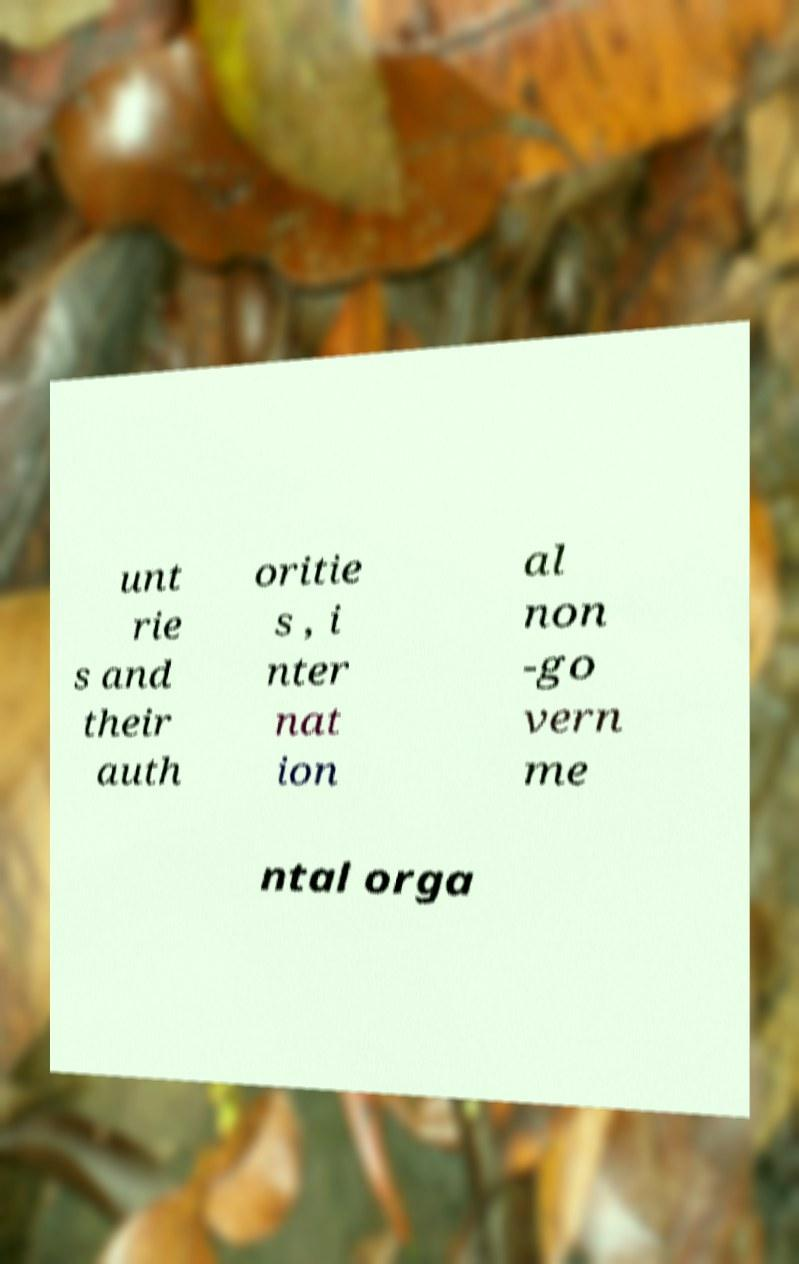Could you assist in decoding the text presented in this image and type it out clearly? unt rie s and their auth oritie s , i nter nat ion al non -go vern me ntal orga 